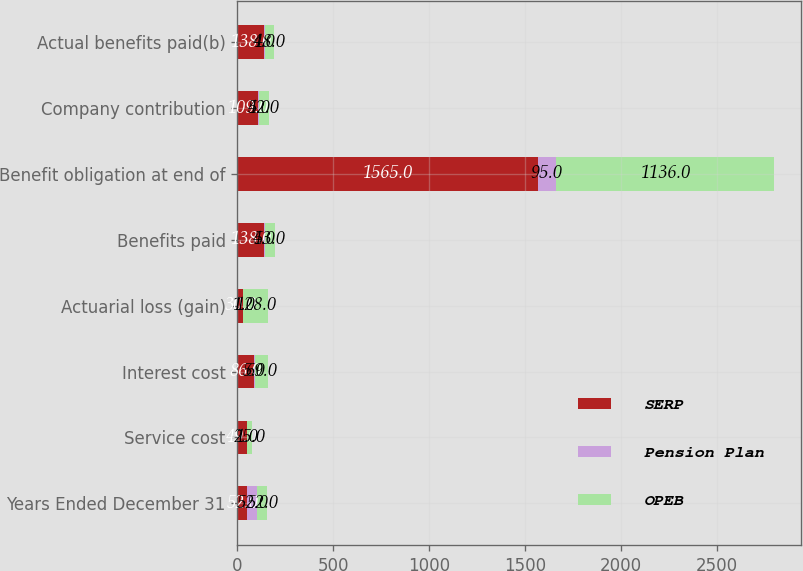Convert chart. <chart><loc_0><loc_0><loc_500><loc_500><stacked_bar_chart><ecel><fcel>Years Ended December 31<fcel>Service cost<fcel>Interest cost<fcel>Actuarial loss (gain)<fcel>Benefits paid<fcel>Benefit obligation at end of<fcel>Company contribution<fcel>Actual benefits paid(b)<nl><fcel>SERP<fcel>52<fcel>49<fcel>86<fcel>30<fcel>138<fcel>1565<fcel>109<fcel>138<nl><fcel>Pension Plan<fcel>52<fcel>1<fcel>5<fcel>1<fcel>4<fcel>95<fcel>4<fcel>4<nl><fcel>OPEB<fcel>52<fcel>25<fcel>69<fcel>128<fcel>53<fcel>1136<fcel>52<fcel>48<nl></chart> 